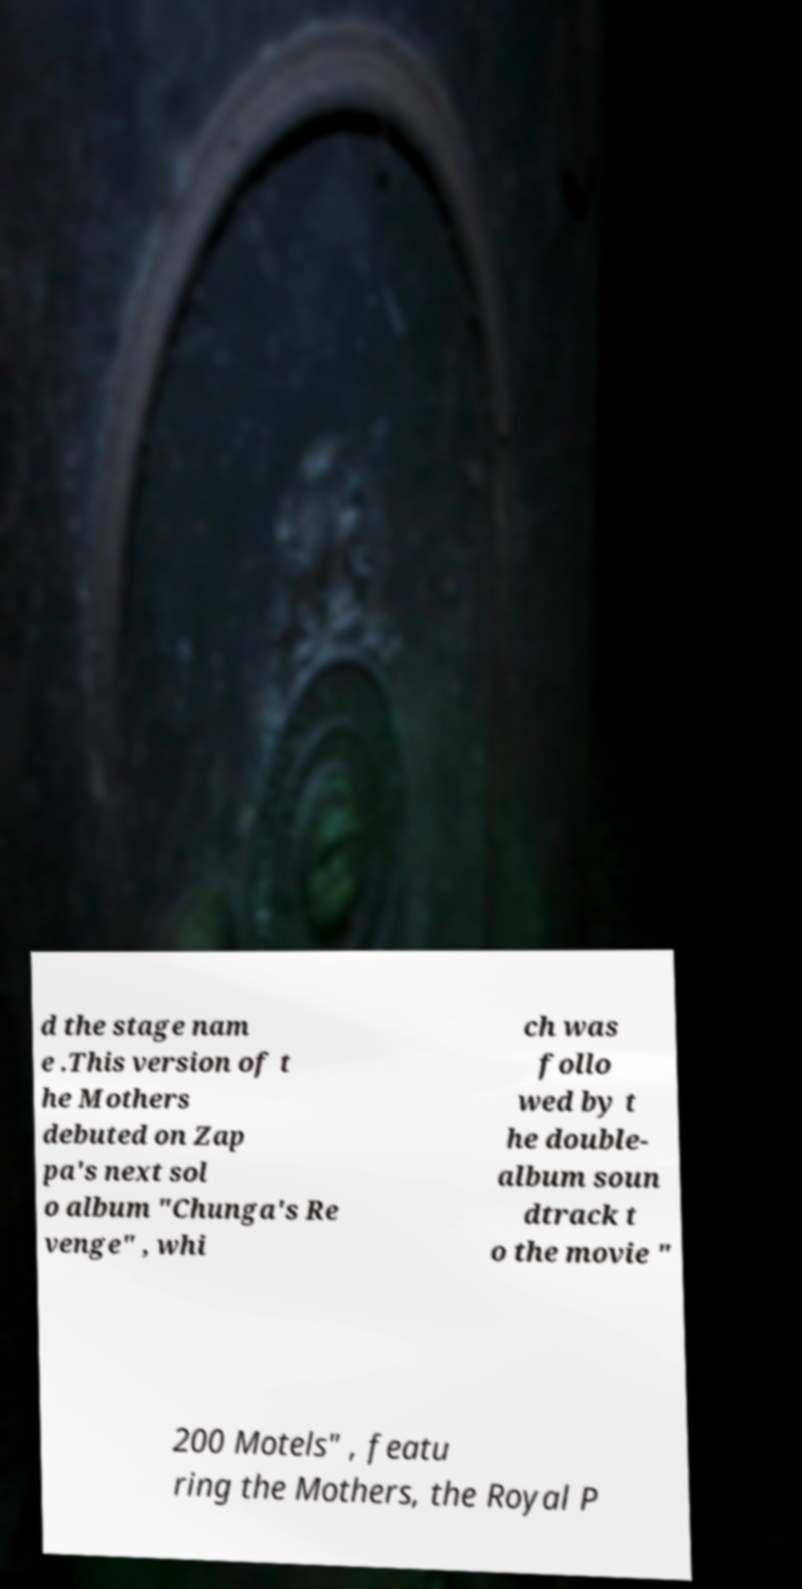Can you accurately transcribe the text from the provided image for me? d the stage nam e .This version of t he Mothers debuted on Zap pa's next sol o album "Chunga's Re venge" , whi ch was follo wed by t he double- album soun dtrack t o the movie " 200 Motels" , featu ring the Mothers, the Royal P 